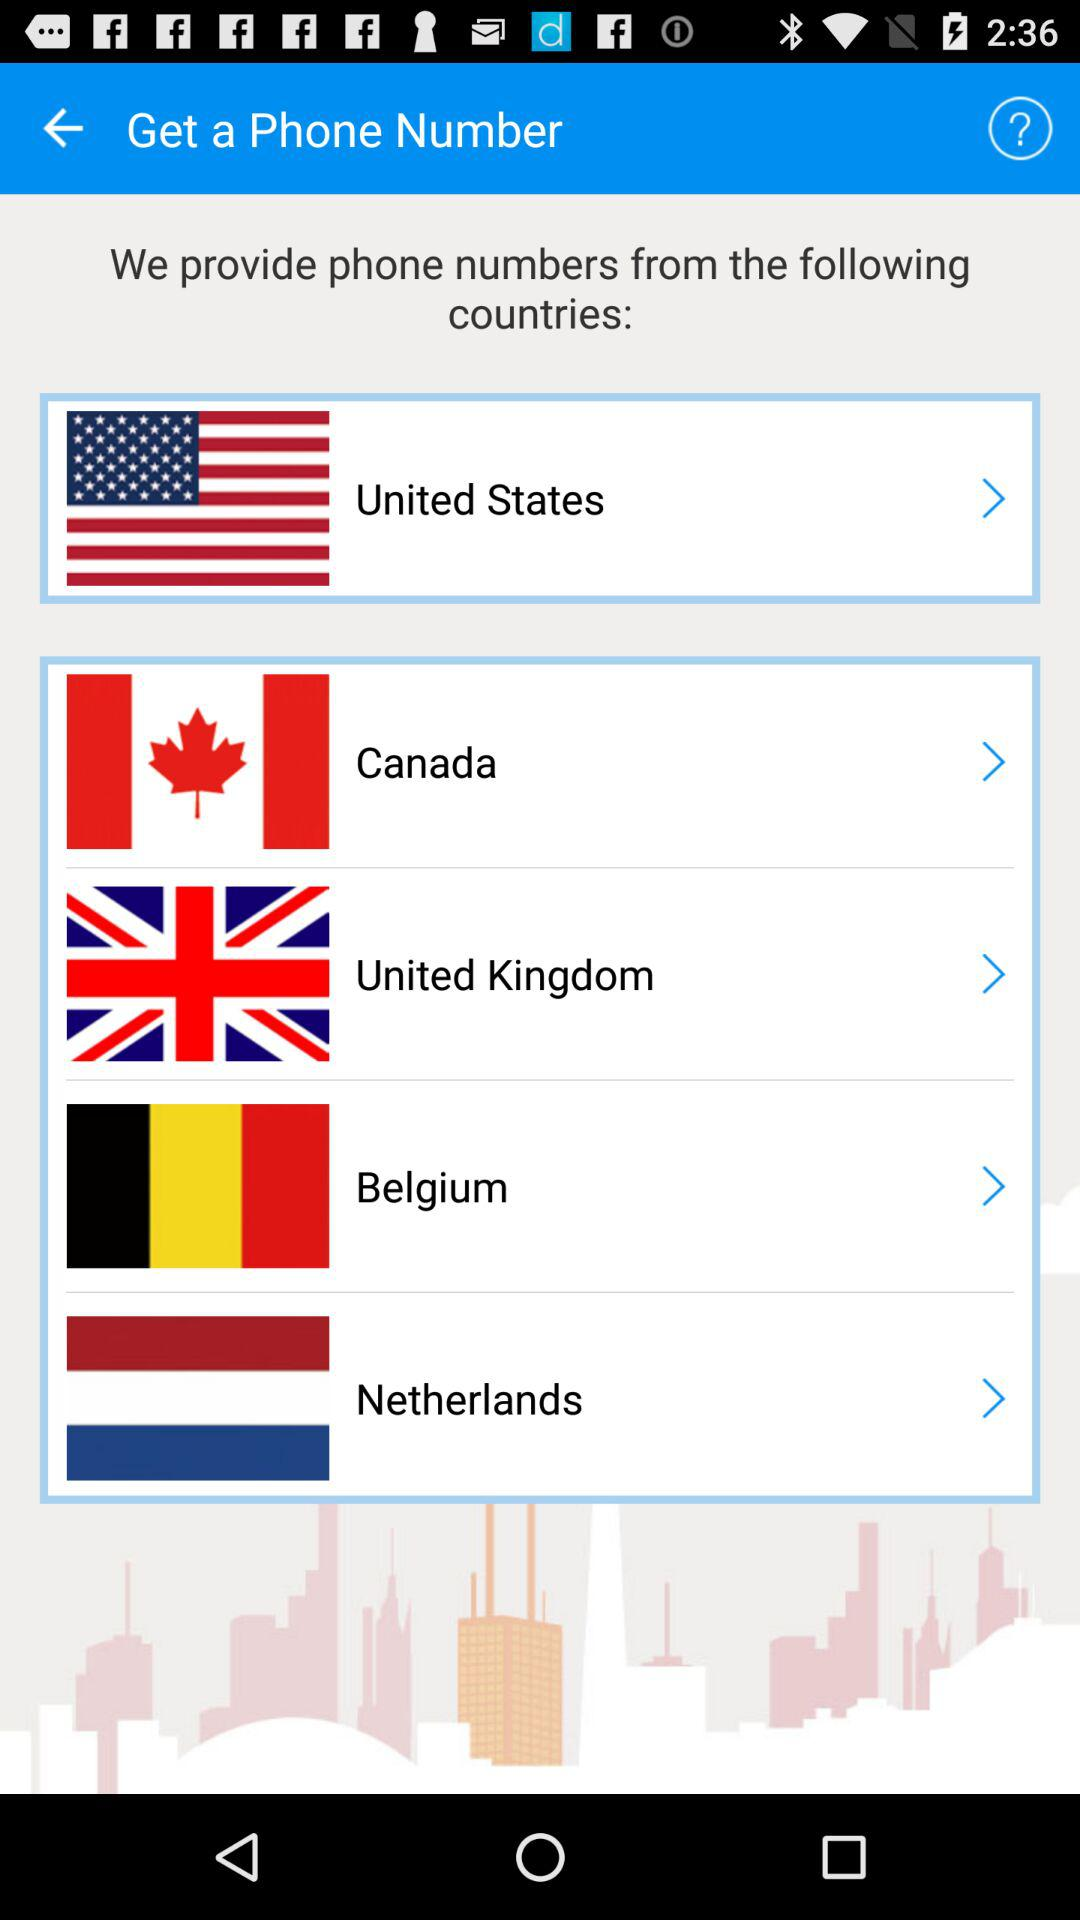From which countries do we provide phone numbers? The countries are the United States, Canada, United Kingdom, Belgium and Netherlands. 